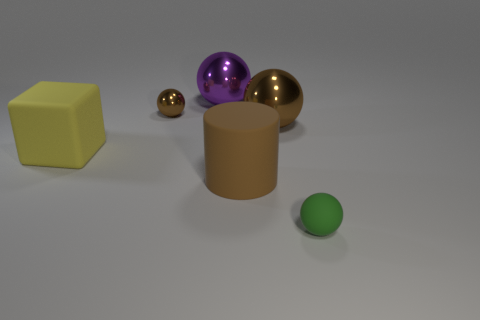Does the rubber cylinder have the same color as the tiny object to the left of the rubber sphere?
Keep it short and to the point. Yes. The sphere that is both behind the big brown ball and in front of the large purple thing is made of what material?
Keep it short and to the point. Metal. What size is the cylinder that is the same color as the tiny metal thing?
Provide a succinct answer. Large. Does the purple shiny thing that is behind the matte cylinder have the same shape as the metallic object to the right of the brown matte cylinder?
Give a very brief answer. Yes. Are any tiny rubber cylinders visible?
Make the answer very short. No. There is another tiny rubber thing that is the same shape as the tiny brown object; what is its color?
Your answer should be very brief. Green. What color is the matte block that is the same size as the matte cylinder?
Your answer should be compact. Yellow. Is the yellow block made of the same material as the small green ball?
Your answer should be compact. Yes. What number of other cylinders are the same color as the rubber cylinder?
Provide a short and direct response. 0. Does the matte block have the same color as the rubber ball?
Your answer should be compact. No. 